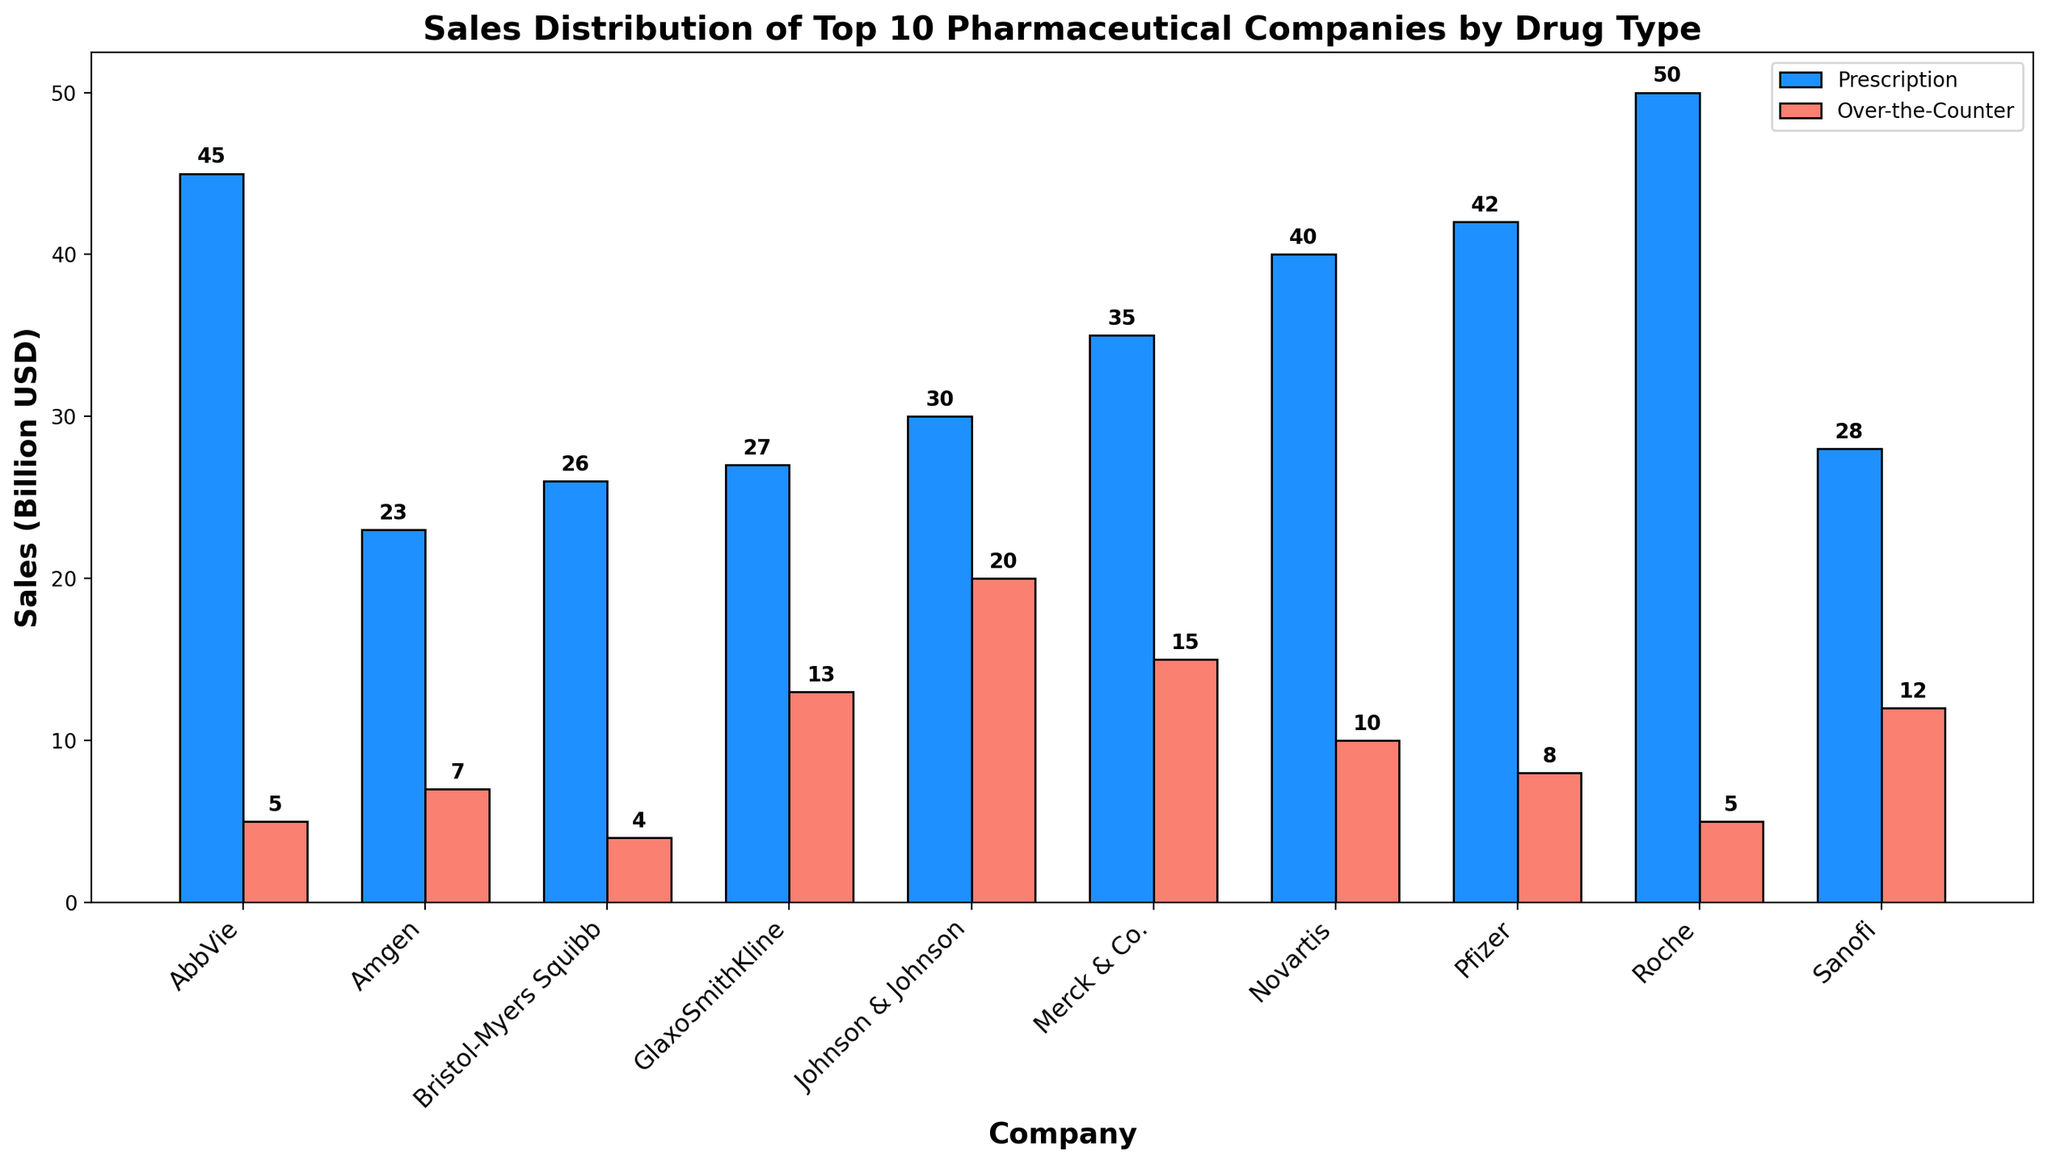What's the total sales for Pfizer? Pfizer has prescription sales of 42 billion USD and over-the-counter sales of 8 billion USD. Adding these together, the total sales for Pfizer are 42 + 8 = 50 billion USD.
Answer: 50 billion USD Which company has the highest prescription drug sales? By comparing the height of the blue bars (prescription), Roche stands out with the highest prescription drug sales at 50 billion USD.
Answer: Roche Which drug type dominates sales for Johnson & Johnson? For Johnson & Johnson, the blue bar (prescription) sales are lower (30 billion USD) compared to the red bar (over-the-counter), which are at 20 billion USD, showing prescription drugs dominate.
Answer: Prescription Is there a company with equal sales for both drug types? By examining the heights of the bars for each company, it is noticeable that there is no company with equal sales for both prescription and over-the-counter drugs.
Answer: No What's the difference in sales between over-the-counter drugs for Merck & Co. and Bristol-Myers Squibb? Merck & Co. has over-the-counter sales of 15 billion USD and Bristol-Myers Squibb has 4 billion USD. The difference is 15 - 4 = 11 billion USD.
Answer: 11 billion USD Which company has the smallest contribution of over-the-counter sales to its total sales? By looking at the heights of the red bars, Bristol-Myers Squibb has the smallest over-the-counter sales (4 billion USD) compared to its prescription sales (26 billion USD).
Answer: Bristol-Myers Squibb On average, how much do the top 10 pharmaceutical companies make from over-the-counter drugs? Sum up all the over-the-counter sales: 8 + 5 + 20 + 10 + 15 + 12 + 13 + 5 + 7 + 4 = 99 billion USD. There are 10 companies, so average is 99/10 = 9.9 billion USD.
Answer: 9.9 billion USD What's the total sales figure for Roche and Novartis combined? Roche's total sales are 50 (prescription) + 5 (over-the-counter) = 55 billion USD. Novartis's total sales are 40 (prescription) + 10 (over-the-counter) = 50 billion USD. Combined, they are 55 + 50 = 105 billion USD.
Answer: 105 billion USD Which company has a higher over-the-counter sales figure: GlaxoSmithKline or Sanofi? GlaxoSmithKline has over-the-counter sales of 13 billion USD, while Sanofi has 12 billion USD. Hence, GlaxoSmithKline has higher over-the-counter sales.
Answer: GlaxoSmithKline What is the ratio of prescription sales to over-the-counter sales for AbbVie? AbbVie has prescription sales of 45 billion USD and over-the-counter sales of 5 billion USD. The ratio is 45/5 = 9.
Answer: 9 